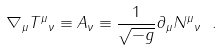Convert formula to latex. <formula><loc_0><loc_0><loc_500><loc_500>\nabla _ { \mu } { T ^ { \mu } } _ { \nu } \equiv A _ { \nu } \equiv \frac { 1 } { \sqrt { - g } } \partial _ { \mu } { N ^ { \mu } } _ { \nu } \ .</formula> 